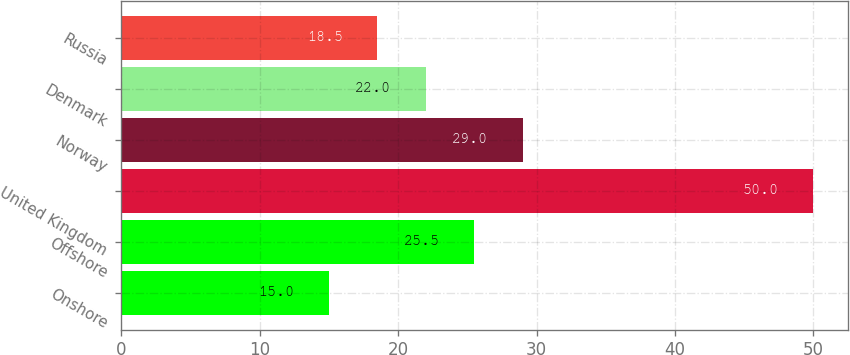Convert chart. <chart><loc_0><loc_0><loc_500><loc_500><bar_chart><fcel>Onshore<fcel>Offshore<fcel>United Kingdom<fcel>Norway<fcel>Denmark<fcel>Russia<nl><fcel>15<fcel>25.5<fcel>50<fcel>29<fcel>22<fcel>18.5<nl></chart> 